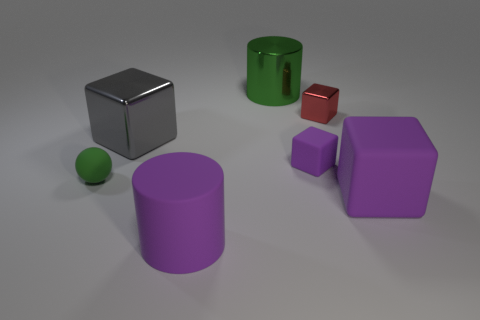Add 2 big green cylinders. How many objects exist? 9 Subtract all cylinders. How many objects are left? 5 Add 6 large blue rubber balls. How many large blue rubber balls exist? 6 Subtract 1 purple cylinders. How many objects are left? 6 Subtract all big brown shiny cubes. Subtract all large gray metallic objects. How many objects are left? 6 Add 2 gray blocks. How many gray blocks are left? 3 